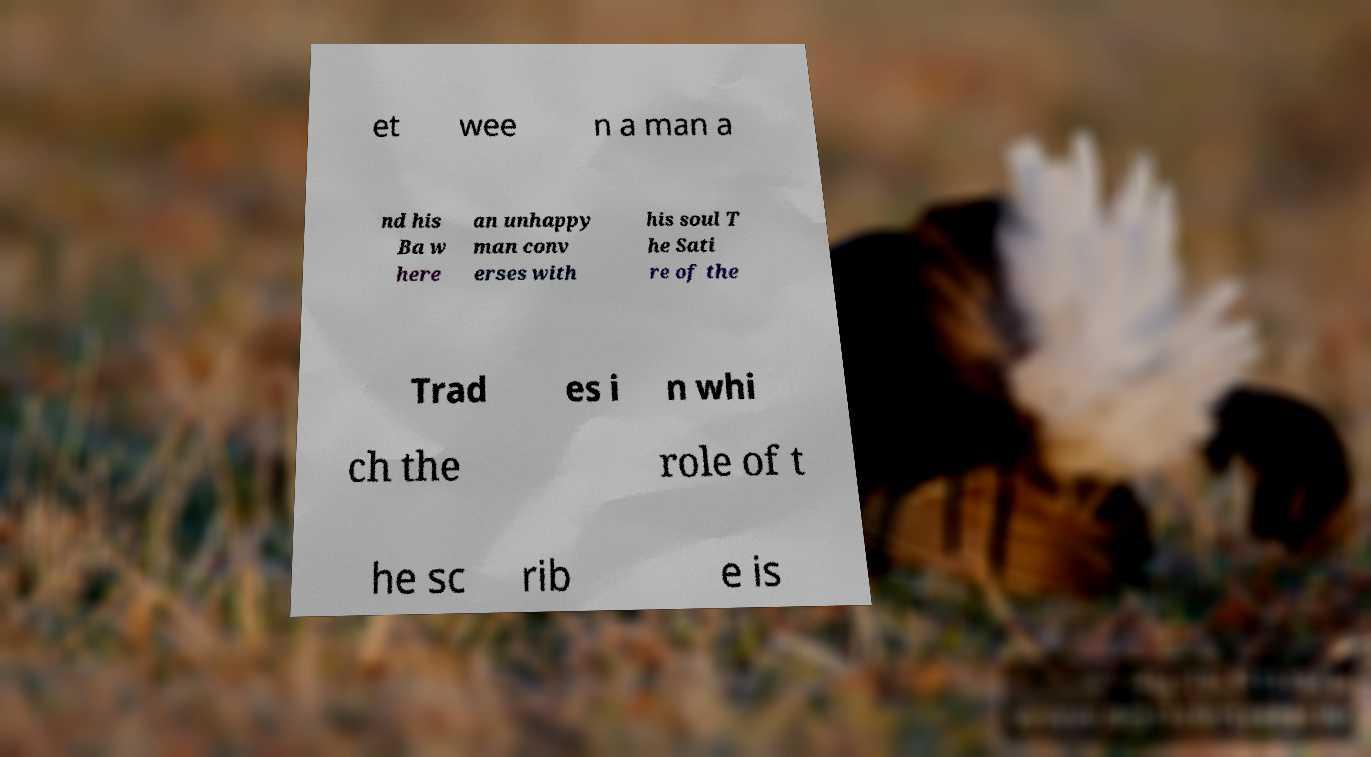Can you read and provide the text displayed in the image?This photo seems to have some interesting text. Can you extract and type it out for me? et wee n a man a nd his Ba w here an unhappy man conv erses with his soul T he Sati re of the Trad es i n whi ch the role of t he sc rib e is 